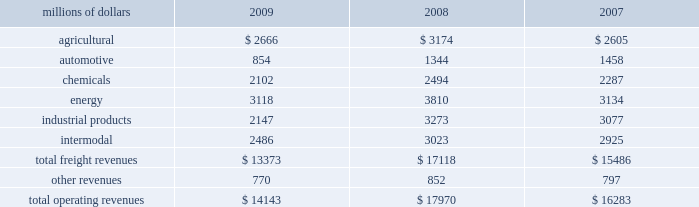Notes to the consolidated financial statements union pacific corporation and subsidiary companies for purposes of this report , unless the context otherwise requires , all references herein to the 201ccorporation 201d , 201cupc 201d , 201cwe 201d , 201cus 201d , and 201cour 201d mean union pacific corporation and its subsidiaries , including union pacific railroad company , which will be separately referred to herein as 201cuprr 201d or the 201crailroad 201d .
Nature of operations operations and segmentation 2013 we are a class i railroad that operates in the united states .
We have 32094 route miles , linking pacific coast and gulf coast ports with the midwest and eastern united states gateways and providing several corridors to key mexican gateways .
We serve the western two- thirds of the country and maintain coordinated schedules with other rail carriers for the handling of freight to and from the atlantic coast , the pacific coast , the southeast , the southwest , canada , and mexico .
Export and import traffic is moved through gulf coast and pacific coast ports and across the mexican and canadian borders .
The railroad , along with its subsidiaries and rail affiliates , is our one reportable operating segment .
Although revenues are analyzed by commodity group , we analyze the net financial results of the railroad as one segment due to the integrated nature of our rail network .
The table provides revenue by commodity group : millions of dollars 2009 2008 2007 .
Although our revenues are principally derived from customers domiciled in the united states , the ultimate points of origination or destination for some products transported are outside the united states .
Basis of presentation 2013 the consolidated financial statements are presented in accordance with accounting principles generally accepted in the united states of america ( gaap ) as codified in the financial accounting standards board ( fasb ) accounting standards codification ( asc ) .
Subsequent events evaluation 2013 we evaluated the effects of all subsequent events through february 5 , 2010 , the date of this report , which is concurrent with the date we file this report with the u.s .
Securities and exchange commission ( sec ) .
Significant accounting policies change in accounting principle 2013 we have historically accounted for rail grinding costs as a capital asset .
Beginning in the first quarter of 2010 , we will change our accounting policy for rail grinding costs .
For 2009 , what was freight revenue per route mile? 
Computations: ((13373 * 1000000) / 32094)
Answer: 416682.2459. Notes to the consolidated financial statements union pacific corporation and subsidiary companies for purposes of this report , unless the context otherwise requires , all references herein to the 201ccorporation 201d , 201cupc 201d , 201cwe 201d , 201cus 201d , and 201cour 201d mean union pacific corporation and its subsidiaries , including union pacific railroad company , which will be separately referred to herein as 201cuprr 201d or the 201crailroad 201d .
Nature of operations operations and segmentation 2013 we are a class i railroad that operates in the united states .
We have 32094 route miles , linking pacific coast and gulf coast ports with the midwest and eastern united states gateways and providing several corridors to key mexican gateways .
We serve the western two- thirds of the country and maintain coordinated schedules with other rail carriers for the handling of freight to and from the atlantic coast , the pacific coast , the southeast , the southwest , canada , and mexico .
Export and import traffic is moved through gulf coast and pacific coast ports and across the mexican and canadian borders .
The railroad , along with its subsidiaries and rail affiliates , is our one reportable operating segment .
Although revenues are analyzed by commodity group , we analyze the net financial results of the railroad as one segment due to the integrated nature of our rail network .
The table provides revenue by commodity group : millions of dollars 2009 2008 2007 .
Although our revenues are principally derived from customers domiciled in the united states , the ultimate points of origination or destination for some products transported are outside the united states .
Basis of presentation 2013 the consolidated financial statements are presented in accordance with accounting principles generally accepted in the united states of america ( gaap ) as codified in the financial accounting standards board ( fasb ) accounting standards codification ( asc ) .
Subsequent events evaluation 2013 we evaluated the effects of all subsequent events through february 5 , 2010 , the date of this report , which is concurrent with the date we file this report with the u.s .
Securities and exchange commission ( sec ) .
Significant accounting policies change in accounting principle 2013 we have historically accounted for rail grinding costs as a capital asset .
Beginning in the first quarter of 2010 , we will change our accounting policy for rail grinding costs .
For the three year period what were cumulative operating revenues? 
Computations: multiply(table_sum(total operating revenues, none), const_1000000)
Answer: 48396000000.0. Notes to the consolidated financial statements union pacific corporation and subsidiary companies for purposes of this report , unless the context otherwise requires , all references herein to the 201ccorporation 201d , 201cupc 201d , 201cwe 201d , 201cus 201d , and 201cour 201d mean union pacific corporation and its subsidiaries , including union pacific railroad company , which will be separately referred to herein as 201cuprr 201d or the 201crailroad 201d .
Nature of operations operations and segmentation 2013 we are a class i railroad that operates in the united states .
We have 32094 route miles , linking pacific coast and gulf coast ports with the midwest and eastern united states gateways and providing several corridors to key mexican gateways .
We serve the western two- thirds of the country and maintain coordinated schedules with other rail carriers for the handling of freight to and from the atlantic coast , the pacific coast , the southeast , the southwest , canada , and mexico .
Export and import traffic is moved through gulf coast and pacific coast ports and across the mexican and canadian borders .
The railroad , along with its subsidiaries and rail affiliates , is our one reportable operating segment .
Although revenues are analyzed by commodity group , we analyze the net financial results of the railroad as one segment due to the integrated nature of our rail network .
The table provides revenue by commodity group : millions of dollars 2009 2008 2007 .
Although our revenues are principally derived from customers domiciled in the united states , the ultimate points of origination or destination for some products transported are outside the united states .
Basis of presentation 2013 the consolidated financial statements are presented in accordance with accounting principles generally accepted in the united states of america ( gaap ) as codified in the financial accounting standards board ( fasb ) accounting standards codification ( asc ) .
Subsequent events evaluation 2013 we evaluated the effects of all subsequent events through february 5 , 2010 , the date of this report , which is concurrent with the date we file this report with the u.s .
Securities and exchange commission ( sec ) .
Significant accounting policies change in accounting principle 2013 we have historically accounted for rail grinding costs as a capital asset .
Beginning in the first quarter of 2010 , we will change our accounting policy for rail grinding costs .
What percent of total freight revenues was the chemicals group in 2009? 
Computations: (2102 / 13373)
Answer: 0.15718. 